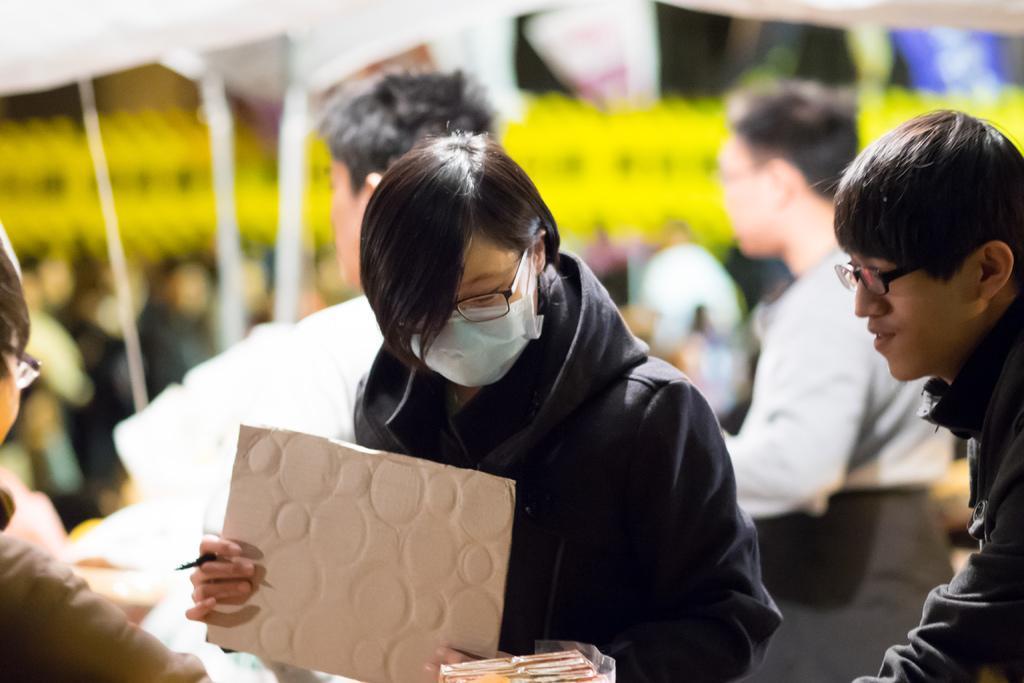Describe this image in one or two sentences. In this image we can see the people standing and holding board and pen. And blur background. 